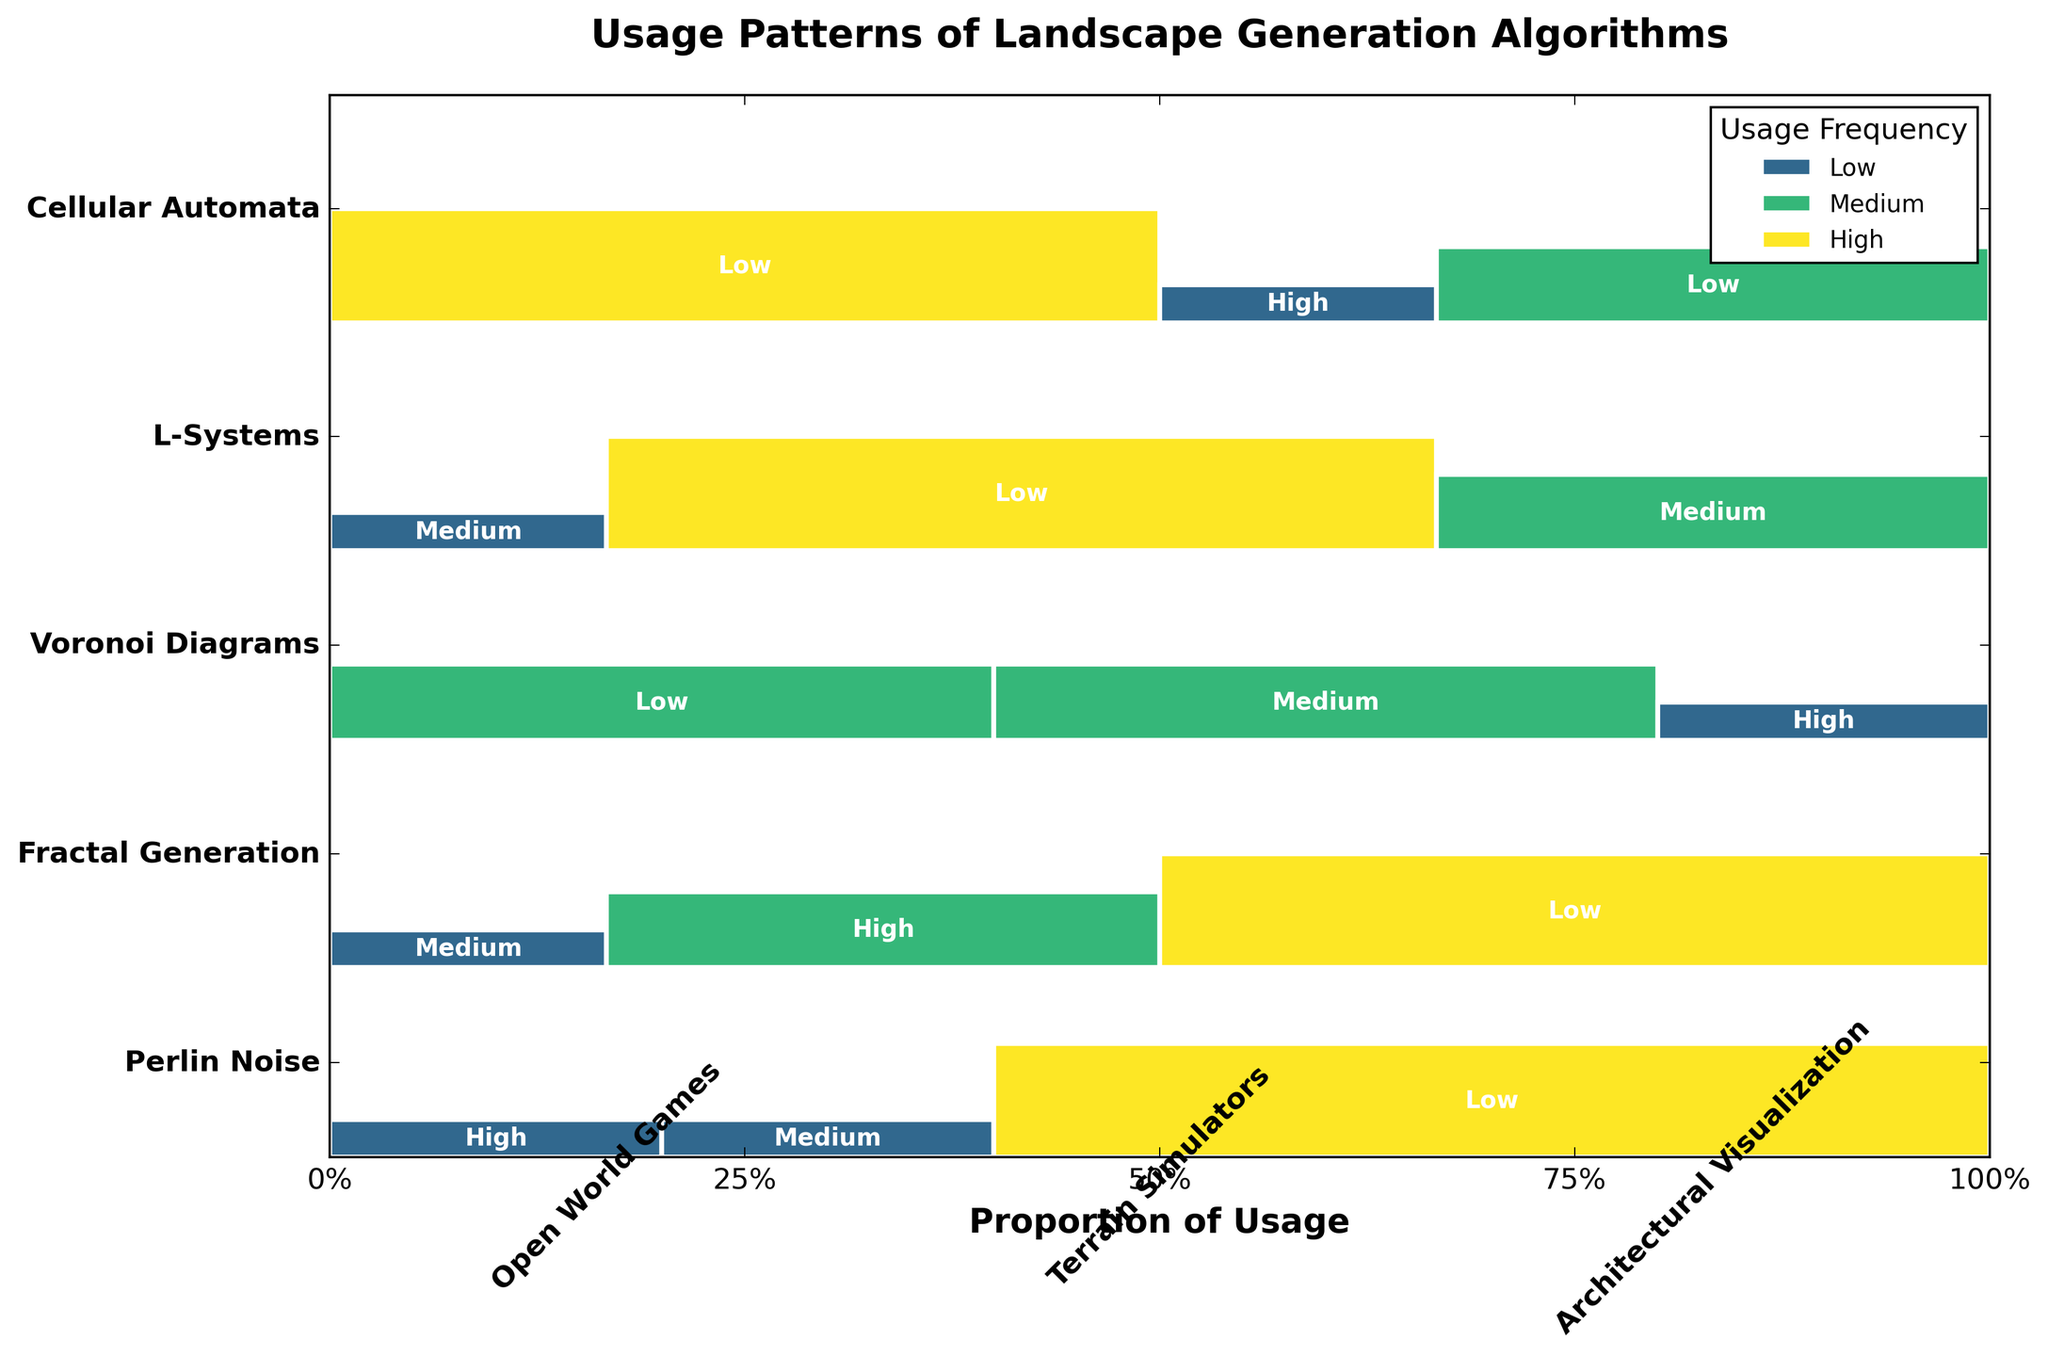What is the title of the figure? The title is usually found at the top of the plot. Observing the title area, the given title is written in bold.
Answer: Usage Patterns of Landscape Generation Algorithms Which algorithm has the highest usage in Terrain Simulators? By looking at the height of the rectangles within the Terrain Simulators section, the tallest rectangle corresponds to the highest usage. Fractal Generation has the tallest rectangle.
Answer: Fractal Generation What is the proportionate usage of Perlin Noise in Terrain Simulators? Examine the width of the Perlin Noise segment in Terrain Simulators. It appears to be shorter than the High usage category but longer than the Low, indicating Medium usage.
Answer: Medium Which project type has the least usage of L-Systems? Analyzing the varying heights of the rectangles under L-Systems, the smallest rectangle corresponds to the lowest usage. The smallest rectangle is found in Terrain Simulators.
Answer: Terrain Simulators How does the usage of Voronoi Diagrams in Architectural Visualization compare to its usage in Open World Games? By comparing the heights of the rectangles for Voronoi Diagrams in the two project types, we see that it is the highest in Architectural Visualization and the lowest in Open World Games.
Answer: Higher in Architectural Visualization, Lower in Open World Games Which algorithm shows a balanced usage across different project types? A balanced usage entails similar height and consistent usage frequencies across project types. Both L-Systems and Perlin Noise exhibit relatively balanced usage patterns with slight variations but no extreme highs or lows.
Answer: L-Systems, Perlin Noise What proportion of the total usage does Fractal Generation contribute to Open World Games? The width of the Fractal Generation rectangle in Open World Games section can be estimated proportionally as it covers a Medium segment compared to others in its row.
Answer: Medium Is the usage of Cellular Automata in Terrain Simulators higher or lower than in Open World Games? By looking at the heights of Cellular Automata rectangles, the height for Terrain Simulators is significantly larger compared to the one in Open World Games.
Answer: Higher in Terrain Simulators What is the usage pattern of Voronoi Diagrams across the three project types? Observing the heights of Voronoi Diagrams rectangles across project types shows a sequence of Low (in Open World Games), Medium (in Terrain Simulators), and High (in Architectural Visualization).
Answer: Low in Open World Games, Medium in Terrain Simulators, High in Architectural Visualization 